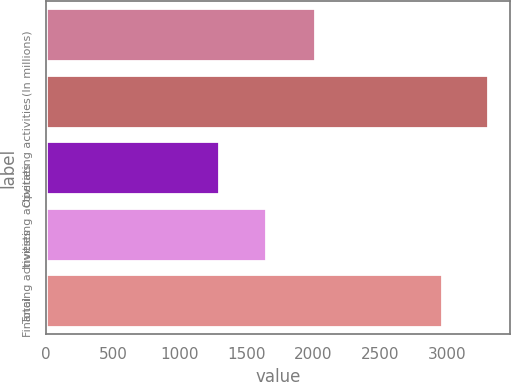Convert chart. <chart><loc_0><loc_0><loc_500><loc_500><bar_chart><fcel>(In millions)<fcel>Operating activities<fcel>Investing activities<fcel>Financing activities<fcel>Total<nl><fcel>2011<fcel>3309<fcel>1295<fcel>1643<fcel>2961<nl></chart> 